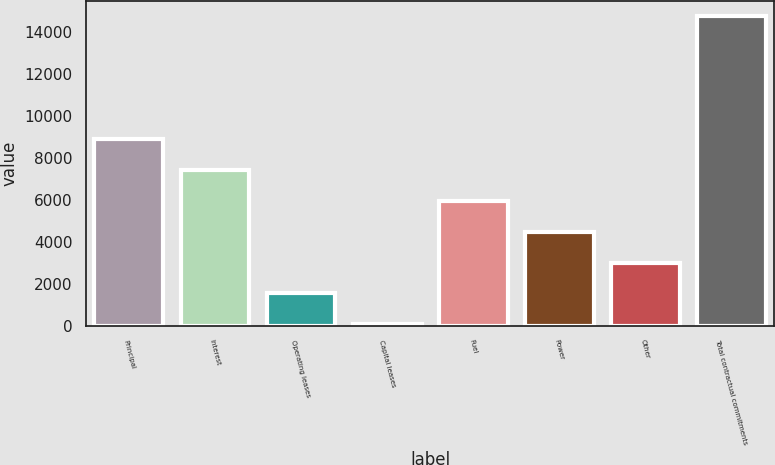Convert chart to OTSL. <chart><loc_0><loc_0><loc_500><loc_500><bar_chart><fcel>Principal<fcel>Interest<fcel>Operating leases<fcel>Capital leases<fcel>Fuel<fcel>Power<fcel>Other<fcel>Total contractual commitments<nl><fcel>8871.58<fcel>7404.85<fcel>1537.93<fcel>71.2<fcel>5938.12<fcel>4471.39<fcel>3004.66<fcel>14738.5<nl></chart> 